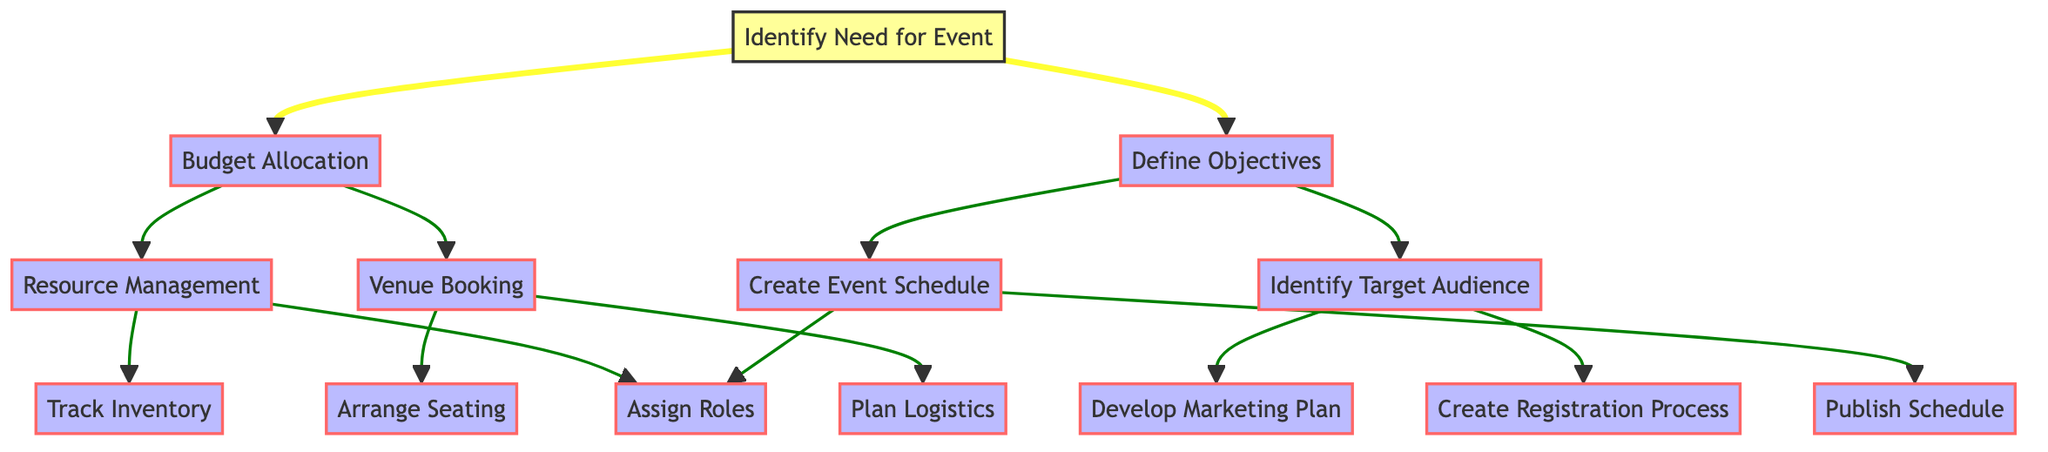What is the first step in the event planning process? The diagram starts at the node "Identify Need for Event," which indicates it is the initial step of the process.
Answer: Identify Need for Event How many steps are there in total in the diagram? By counting the distinct nodes presented in the diagram, we can identify that there are a total of 13 steps.
Answer: 13 What follows after "Budget Allocation"? The diagram shows that after "Budget Allocation," the next steps are "Resource Management" and "Venue Booking" indicated by direct arrows leading from "Budget Allocation."
Answer: Resource Management, Venue Booking Which node is a direct successor of "Define Objectives"? The direct successors of "Define Objectives" are "Identify Target Audience" and "Create Event Schedule," as they are the next nodes connected by arrows from "Define Objectives."
Answer: Identify Target Audience, Create Event Schedule What is the purpose of the "Assign Roles" step? "Assign Roles" is responsible for assigning specific tasks and responsibilities to team members, which is highlighted in its description in the diagram.
Answer: Assign specific tasks and responsibilities Which nodes lead directly to the "Plan Logistics" step? Only "Venue Booking" leads directly to "Plan Logistics," as shown by the arrow connecting those two nodes in the diagram.
Answer: Venue Booking What step directly comes after "Create Registration Process"? The flow chart indicates that "Create Registration Process" leads directly to "Develop Registration Form" and "Manage Registrations," showing these steps can happen next.
Answer: Develop Registration Form, Manage Registrations What are the last steps that follow "Publish Schedule"? The last steps indicated after "Publish Schedule" are "Send Notifications" and "Update Schedule if Needed," which are connected by arrows leading from "Publish Schedule."
Answer: Send Notifications, Update Schedule if Needed Which two nodes connect to "Assign Roles"? "Create Event Schedule" and "Resource Management" both connect to "Assign Roles," as it has arrows leading to it from these two nodes in the diagram.
Answer: Create Event Schedule, Resource Management 